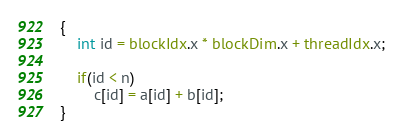<code> <loc_0><loc_0><loc_500><loc_500><_Cuda_>{
	int id = blockIdx.x * blockDim.x + threadIdx.x;

	if(id < n)
		c[id] = a[id] + b[id];
}
</code> 